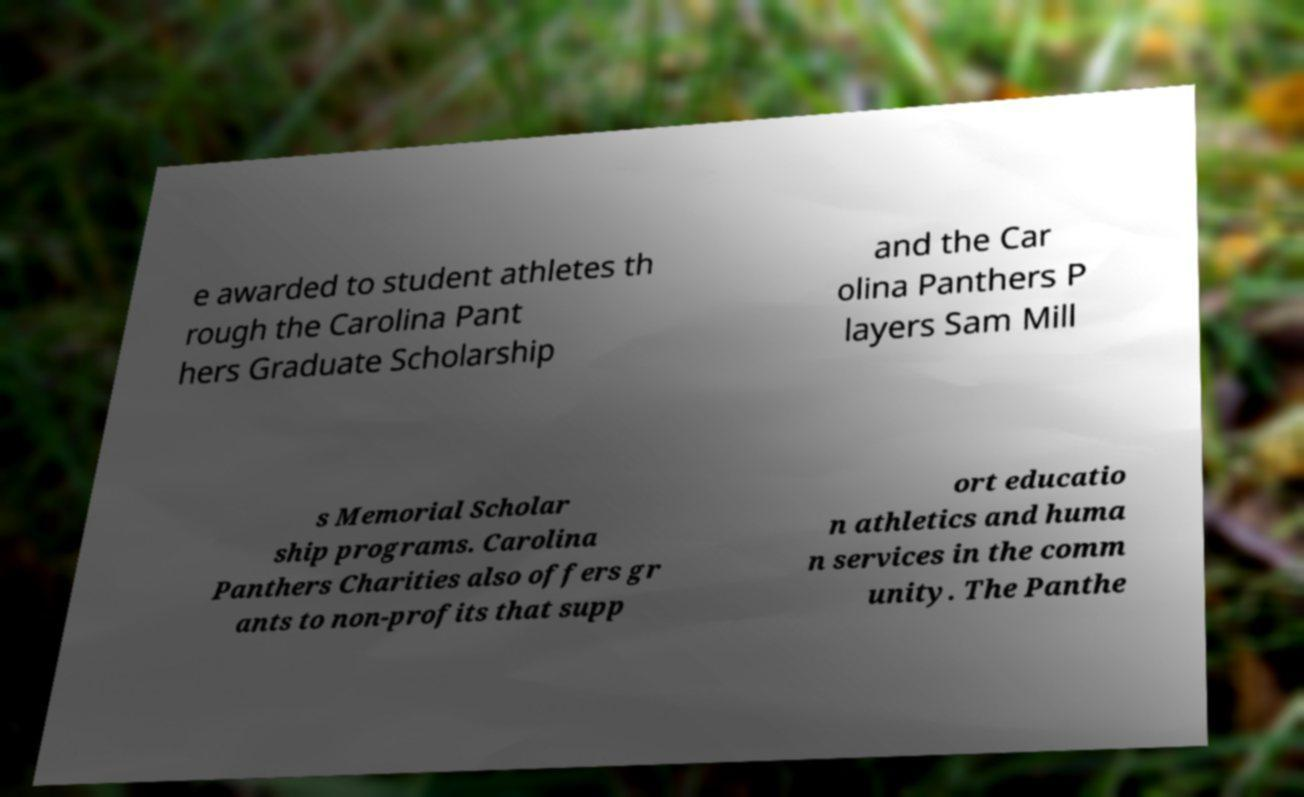Could you extract and type out the text from this image? e awarded to student athletes th rough the Carolina Pant hers Graduate Scholarship and the Car olina Panthers P layers Sam Mill s Memorial Scholar ship programs. Carolina Panthers Charities also offers gr ants to non-profits that supp ort educatio n athletics and huma n services in the comm unity. The Panthe 